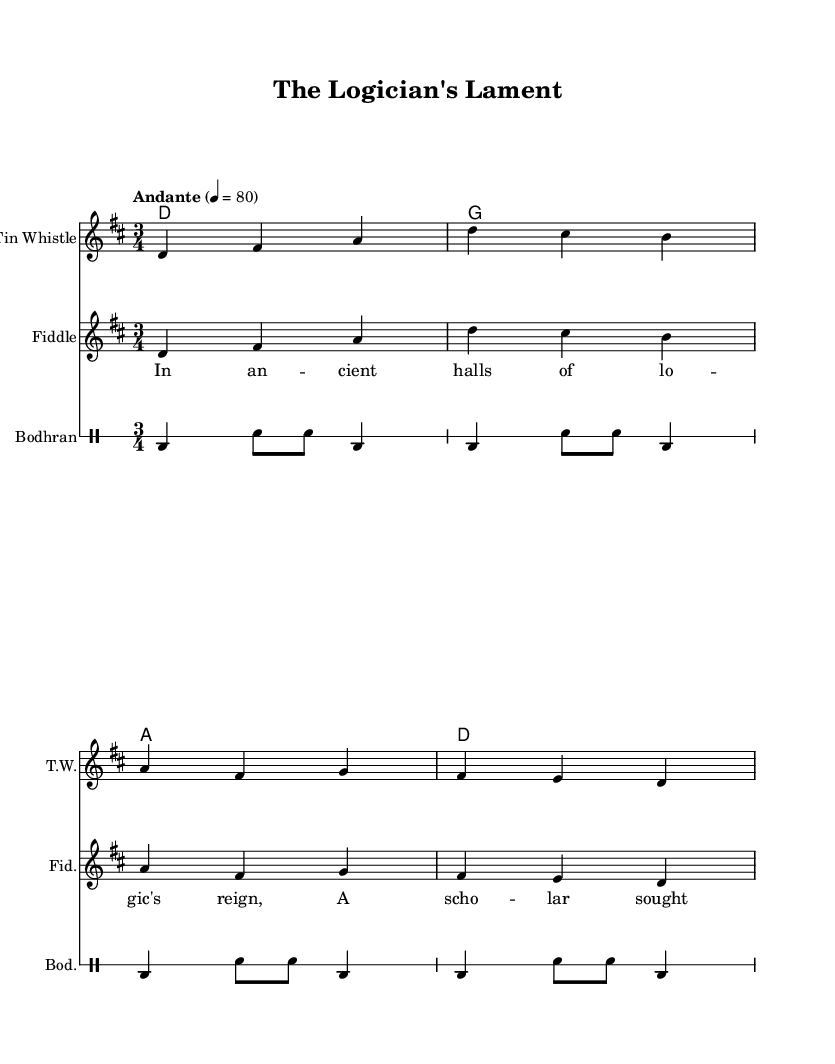What is the key signature of this music? The key signature is indicated at the beginning of the staff, showing two sharps (F# and C#) which means it is in D major.
Answer: D major What is the time signature of this piece? The time signature is shown at the beginning of the score, indicating the music is in a 3/4 meter, meaning there are three beats in each measure.
Answer: 3/4 What is the tempo marking for the piece? The tempo is indicated above the staff as "Andante," which suggests a moderately slow pace of 80 beats per minute.
Answer: Andante How many beats are there in one measure? The time signature of 3/4 indicates that there are three beats in each measure. Therefore, the answer is derived from the time signature.
Answer: 3 What instruments are used in this score? The score includes three instruments: Tin Whistle, Fiddle, and Bodhran, as listed under each staff.
Answer: Tin Whistle, Fiddle, Bodhran What is the first lyric line of the song? The lyrics section indicates the first line begins with "In an," providing the title of the lyric. This is also the beginning of the verse indicated in the score.
Answer: In an -- cient halls of lo -- gic's reign What is the chord progression used in the harmonies? The chord symbols written over the measures indicate a progression of D, G, A, and D in that order. This can be inferred from the chordmode section of the code.
Answer: D, G, A, D 